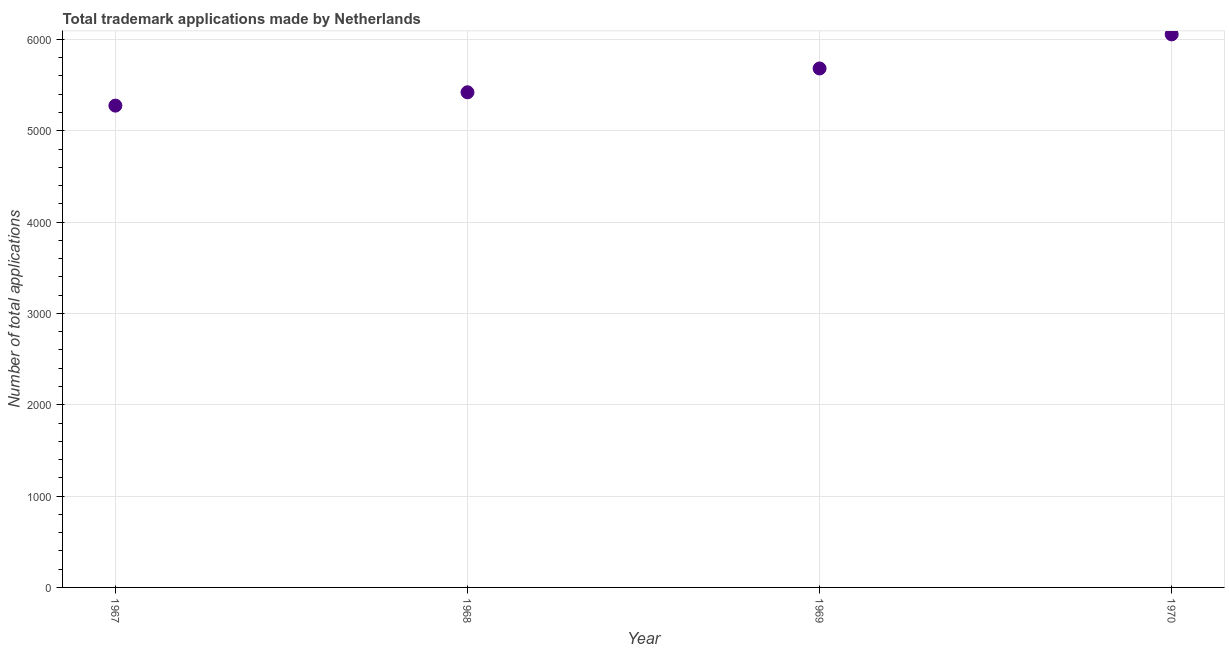What is the number of trademark applications in 1968?
Your response must be concise. 5421. Across all years, what is the maximum number of trademark applications?
Give a very brief answer. 6055. Across all years, what is the minimum number of trademark applications?
Provide a succinct answer. 5275. In which year was the number of trademark applications maximum?
Ensure brevity in your answer.  1970. In which year was the number of trademark applications minimum?
Give a very brief answer. 1967. What is the sum of the number of trademark applications?
Your answer should be very brief. 2.24e+04. What is the difference between the number of trademark applications in 1969 and 1970?
Ensure brevity in your answer.  -373. What is the average number of trademark applications per year?
Keep it short and to the point. 5608.25. What is the median number of trademark applications?
Give a very brief answer. 5551.5. In how many years, is the number of trademark applications greater than 600 ?
Make the answer very short. 4. Do a majority of the years between 1970 and 1969 (inclusive) have number of trademark applications greater than 1000 ?
Keep it short and to the point. No. What is the ratio of the number of trademark applications in 1967 to that in 1970?
Ensure brevity in your answer.  0.87. Is the number of trademark applications in 1968 less than that in 1969?
Offer a terse response. Yes. What is the difference between the highest and the second highest number of trademark applications?
Offer a terse response. 373. Is the sum of the number of trademark applications in 1967 and 1968 greater than the maximum number of trademark applications across all years?
Provide a succinct answer. Yes. What is the difference between the highest and the lowest number of trademark applications?
Your answer should be very brief. 780. How many dotlines are there?
Provide a short and direct response. 1. How many years are there in the graph?
Your response must be concise. 4. Are the values on the major ticks of Y-axis written in scientific E-notation?
Your response must be concise. No. Does the graph contain any zero values?
Provide a succinct answer. No. What is the title of the graph?
Provide a succinct answer. Total trademark applications made by Netherlands. What is the label or title of the X-axis?
Keep it short and to the point. Year. What is the label or title of the Y-axis?
Provide a short and direct response. Number of total applications. What is the Number of total applications in 1967?
Provide a succinct answer. 5275. What is the Number of total applications in 1968?
Ensure brevity in your answer.  5421. What is the Number of total applications in 1969?
Keep it short and to the point. 5682. What is the Number of total applications in 1970?
Give a very brief answer. 6055. What is the difference between the Number of total applications in 1967 and 1968?
Your answer should be compact. -146. What is the difference between the Number of total applications in 1967 and 1969?
Your answer should be very brief. -407. What is the difference between the Number of total applications in 1967 and 1970?
Keep it short and to the point. -780. What is the difference between the Number of total applications in 1968 and 1969?
Ensure brevity in your answer.  -261. What is the difference between the Number of total applications in 1968 and 1970?
Provide a short and direct response. -634. What is the difference between the Number of total applications in 1969 and 1970?
Provide a succinct answer. -373. What is the ratio of the Number of total applications in 1967 to that in 1969?
Give a very brief answer. 0.93. What is the ratio of the Number of total applications in 1967 to that in 1970?
Keep it short and to the point. 0.87. What is the ratio of the Number of total applications in 1968 to that in 1969?
Give a very brief answer. 0.95. What is the ratio of the Number of total applications in 1968 to that in 1970?
Keep it short and to the point. 0.9. What is the ratio of the Number of total applications in 1969 to that in 1970?
Provide a succinct answer. 0.94. 